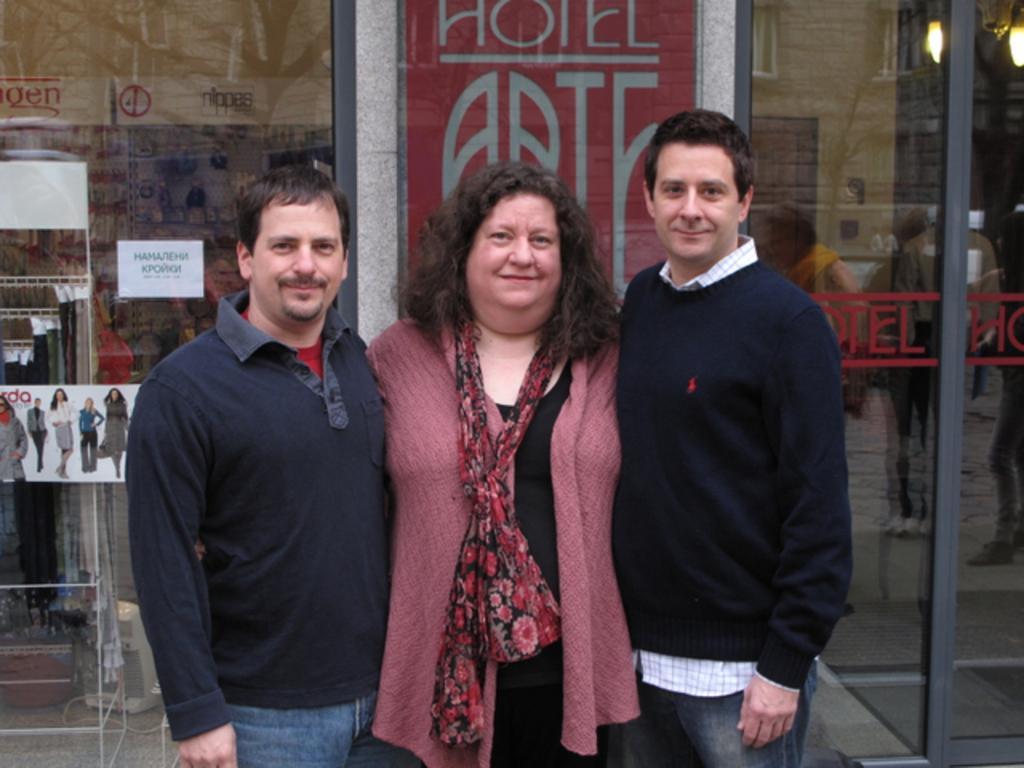Please provide a concise description of this image. In this picture there are three persons standing and smiling. At the back there is a building and there is a glass wall and there are reflections of group of people on the mirror and there is a reflection of building, tree and there are lights behind the mirror and there are papers and posters on the mirror. At the bottom there is a floor. 